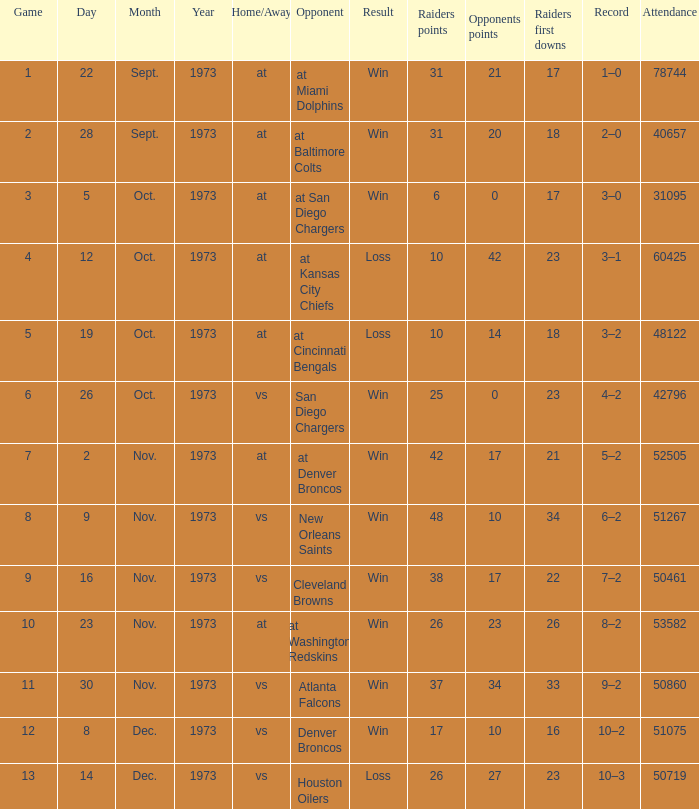What was the result of the game seen by 31095 people? Win. 